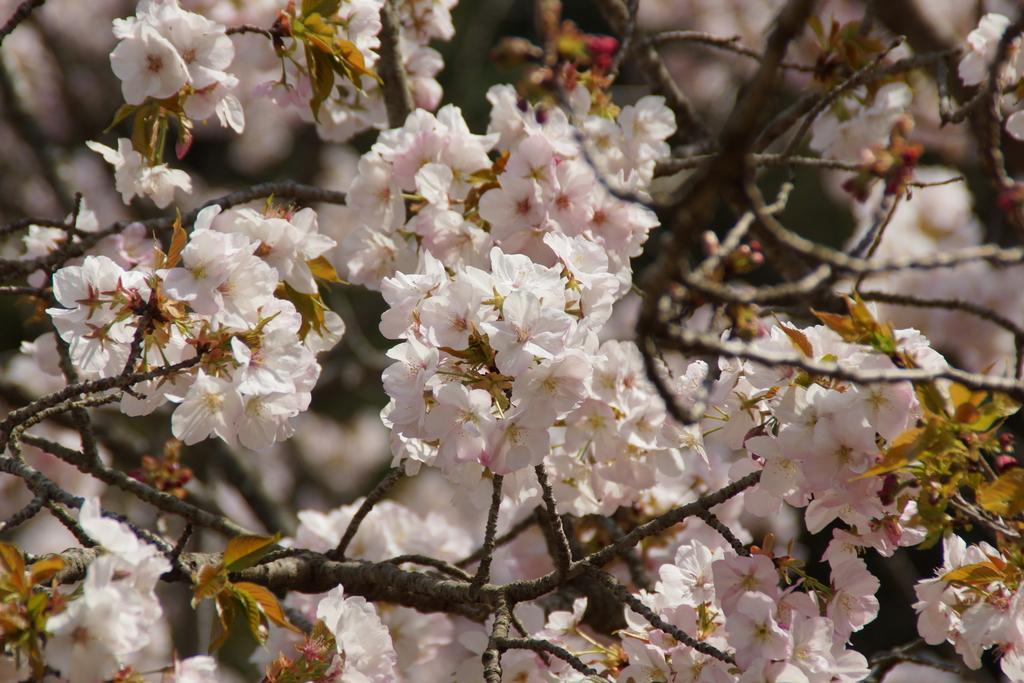What is present in the image? There is a tree in the image. What specific feature can be observed on the tree? The tree has flowers. Can you describe the background of the image? The background of the image is blurred. What type of crack can be seen on the tree trunk in the image? There is no crack visible on the tree trunk in the image. How does the beginner gardener take care of the tree in the image? There is no information about a gardener or their skill level in the image. What type of ornament is hanging from the tree branches in the image? There is no ornament visible on the tree branches in the image. 